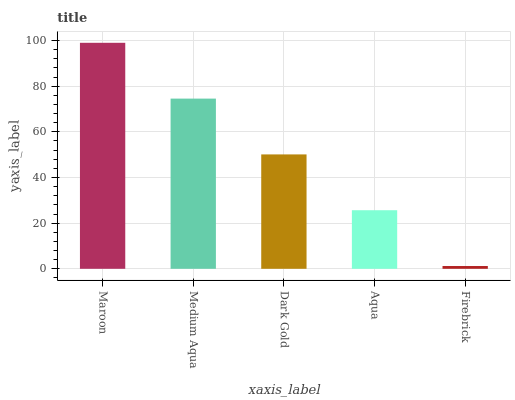Is Medium Aqua the minimum?
Answer yes or no. No. Is Medium Aqua the maximum?
Answer yes or no. No. Is Maroon greater than Medium Aqua?
Answer yes or no. Yes. Is Medium Aqua less than Maroon?
Answer yes or no. Yes. Is Medium Aqua greater than Maroon?
Answer yes or no. No. Is Maroon less than Medium Aqua?
Answer yes or no. No. Is Dark Gold the high median?
Answer yes or no. Yes. Is Dark Gold the low median?
Answer yes or no. Yes. Is Aqua the high median?
Answer yes or no. No. Is Medium Aqua the low median?
Answer yes or no. No. 